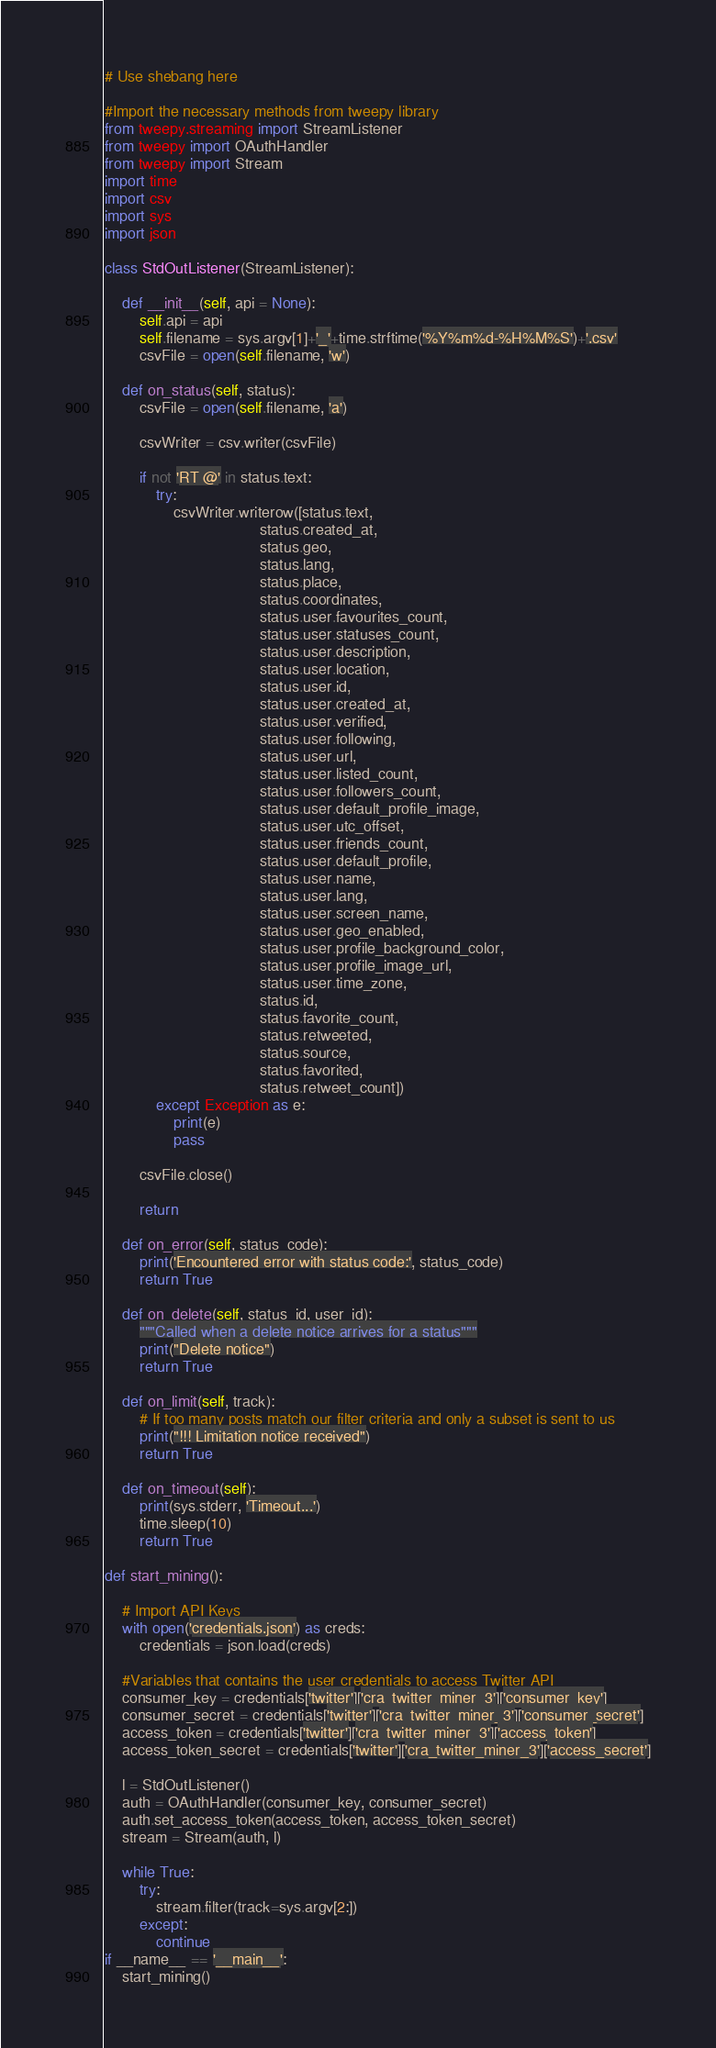<code> <loc_0><loc_0><loc_500><loc_500><_Python_># Use shebang here

#Import the necessary methods from tweepy library
from tweepy.streaming import StreamListener
from tweepy import OAuthHandler
from tweepy import Stream
import time
import csv
import sys
import json

class StdOutListener(StreamListener):

    def __init__(self, api = None):
        self.api = api
        self.filename = sys.argv[1]+'_'+time.strftime('%Y%m%d-%H%M%S')+'.csv'
        csvFile = open(self.filename, 'w')

    def on_status(self, status):
        csvFile = open(self.filename, 'a')

        csvWriter = csv.writer(csvFile)

        if not 'RT @' in status.text:
            try:
                csvWriter.writerow([status.text,
                                    status.created_at,
                                    status.geo,
                                    status.lang,
                                    status.place,
                                    status.coordinates,
                                    status.user.favourites_count,
                                    status.user.statuses_count,
                                    status.user.description,
                                    status.user.location,
                                    status.user.id,
                                    status.user.created_at,
                                    status.user.verified,
                                    status.user.following,
                                    status.user.url,
                                    status.user.listed_count,
                                    status.user.followers_count,
                                    status.user.default_profile_image,
                                    status.user.utc_offset,
                                    status.user.friends_count,
                                    status.user.default_profile,
                                    status.user.name,
                                    status.user.lang,
                                    status.user.screen_name,
                                    status.user.geo_enabled,
                                    status.user.profile_background_color,
                                    status.user.profile_image_url,
                                    status.user.time_zone,
                                    status.id,
                                    status.favorite_count,
                                    status.retweeted,
                                    status.source,
                                    status.favorited,
                                    status.retweet_count])
            except Exception as e:
                print(e)
                pass

        csvFile.close()

        return

    def on_error(self, status_code):
        print('Encountered error with status code:', status_code)
        return True

    def on_delete(self, status_id, user_id):
        """Called when a delete notice arrives for a status"""
        print("Delete notice")
        return True

    def on_limit(self, track):
        # If too many posts match our filter criteria and only a subset is sent to us
        print("!!! Limitation notice received")
        return True

    def on_timeout(self):
        print(sys.stderr, 'Timeout...')
        time.sleep(10)
        return True

def start_mining():

    # Import API Keys
    with open('credentials.json') as creds:
        credentials = json.load(creds)

    #Variables that contains the user credentials to access Twitter API
    consumer_key = credentials['twitter']['cra_twitter_miner_3']['consumer_key']
    consumer_secret = credentials['twitter']['cra_twitter_miner_3']['consumer_secret']
    access_token = credentials['twitter']['cra_twitter_miner_3']['access_token']
    access_token_secret = credentials['twitter']['cra_twitter_miner_3']['access_secret']

    l = StdOutListener()
    auth = OAuthHandler(consumer_key, consumer_secret)
    auth.set_access_token(access_token, access_token_secret)
    stream = Stream(auth, l)

    while True:
        try:
            stream.filter(track=sys.argv[2:])
        except:
            continue
if __name__ == '__main__':
    start_mining()
</code> 